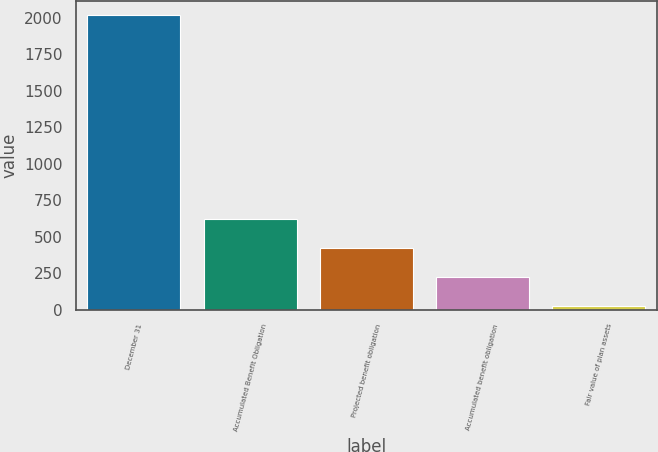Convert chart. <chart><loc_0><loc_0><loc_500><loc_500><bar_chart><fcel>December 31<fcel>Accumulated Benefit Obligation<fcel>Projected benefit obligation<fcel>Accumulated benefit obligation<fcel>Fair value of plan assets<nl><fcel>2016<fcel>622.3<fcel>423.2<fcel>224.1<fcel>25<nl></chart> 